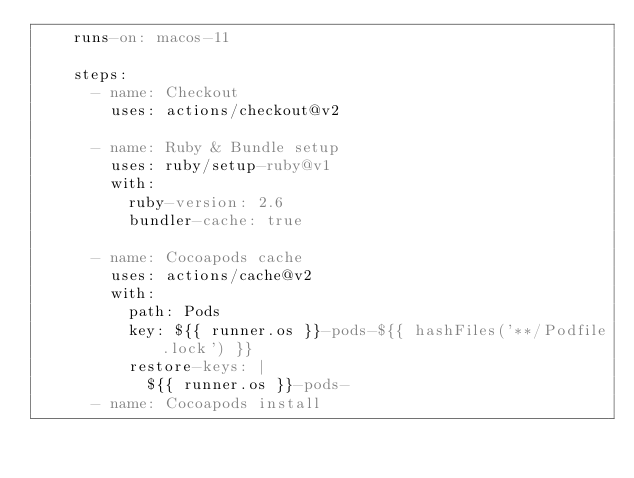Convert code to text. <code><loc_0><loc_0><loc_500><loc_500><_YAML_>    runs-on: macos-11

    steps:
      - name: Checkout
        uses: actions/checkout@v2

      - name: Ruby & Bundle setup
        uses: ruby/setup-ruby@v1
        with:
          ruby-version: 2.6
          bundler-cache: true

      - name: Cocoapods cache
        uses: actions/cache@v2
        with:
          path: Pods
          key: ${{ runner.os }}-pods-${{ hashFiles('**/Podfile.lock') }}
          restore-keys: |
            ${{ runner.os }}-pods-
      - name: Cocoapods install</code> 